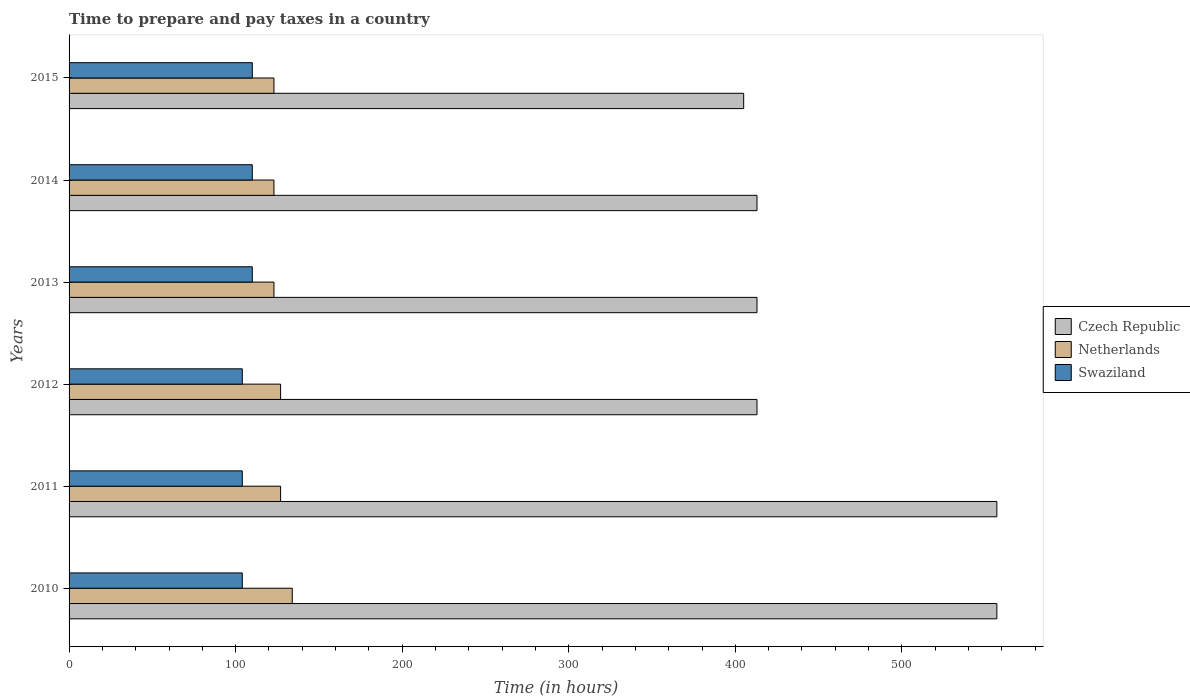How many groups of bars are there?
Make the answer very short. 6. Are the number of bars per tick equal to the number of legend labels?
Your response must be concise. Yes. Are the number of bars on each tick of the Y-axis equal?
Offer a very short reply. Yes. What is the label of the 6th group of bars from the top?
Your answer should be very brief. 2010. In how many cases, is the number of bars for a given year not equal to the number of legend labels?
Keep it short and to the point. 0. What is the number of hours required to prepare and pay taxes in Swaziland in 2011?
Your answer should be compact. 104. Across all years, what is the maximum number of hours required to prepare and pay taxes in Czech Republic?
Ensure brevity in your answer.  557. Across all years, what is the minimum number of hours required to prepare and pay taxes in Netherlands?
Provide a short and direct response. 123. In which year was the number of hours required to prepare and pay taxes in Czech Republic minimum?
Your response must be concise. 2015. What is the total number of hours required to prepare and pay taxes in Czech Republic in the graph?
Provide a short and direct response. 2758. What is the difference between the number of hours required to prepare and pay taxes in Netherlands in 2010 and that in 2012?
Provide a short and direct response. 7. What is the difference between the number of hours required to prepare and pay taxes in Netherlands in 2011 and the number of hours required to prepare and pay taxes in Swaziland in 2015?
Keep it short and to the point. 17. What is the average number of hours required to prepare and pay taxes in Czech Republic per year?
Make the answer very short. 459.67. In the year 2014, what is the difference between the number of hours required to prepare and pay taxes in Netherlands and number of hours required to prepare and pay taxes in Czech Republic?
Make the answer very short. -290. What is the ratio of the number of hours required to prepare and pay taxes in Czech Republic in 2011 to that in 2013?
Make the answer very short. 1.35. Is the difference between the number of hours required to prepare and pay taxes in Netherlands in 2011 and 2015 greater than the difference between the number of hours required to prepare and pay taxes in Czech Republic in 2011 and 2015?
Your answer should be very brief. No. What is the difference between the highest and the lowest number of hours required to prepare and pay taxes in Netherlands?
Offer a terse response. 11. In how many years, is the number of hours required to prepare and pay taxes in Swaziland greater than the average number of hours required to prepare and pay taxes in Swaziland taken over all years?
Your response must be concise. 3. Is the sum of the number of hours required to prepare and pay taxes in Netherlands in 2013 and 2015 greater than the maximum number of hours required to prepare and pay taxes in Czech Republic across all years?
Ensure brevity in your answer.  No. What does the 3rd bar from the top in 2015 represents?
Offer a very short reply. Czech Republic. What does the 2nd bar from the bottom in 2010 represents?
Make the answer very short. Netherlands. Is it the case that in every year, the sum of the number of hours required to prepare and pay taxes in Netherlands and number of hours required to prepare and pay taxes in Czech Republic is greater than the number of hours required to prepare and pay taxes in Swaziland?
Provide a succinct answer. Yes. How many years are there in the graph?
Keep it short and to the point. 6. Does the graph contain any zero values?
Keep it short and to the point. No. Where does the legend appear in the graph?
Ensure brevity in your answer.  Center right. How are the legend labels stacked?
Your answer should be very brief. Vertical. What is the title of the graph?
Offer a very short reply. Time to prepare and pay taxes in a country. Does "Azerbaijan" appear as one of the legend labels in the graph?
Provide a short and direct response. No. What is the label or title of the X-axis?
Provide a succinct answer. Time (in hours). What is the label or title of the Y-axis?
Give a very brief answer. Years. What is the Time (in hours) in Czech Republic in 2010?
Give a very brief answer. 557. What is the Time (in hours) in Netherlands in 2010?
Your answer should be very brief. 134. What is the Time (in hours) of Swaziland in 2010?
Give a very brief answer. 104. What is the Time (in hours) of Czech Republic in 2011?
Give a very brief answer. 557. What is the Time (in hours) of Netherlands in 2011?
Offer a terse response. 127. What is the Time (in hours) in Swaziland in 2011?
Make the answer very short. 104. What is the Time (in hours) in Czech Republic in 2012?
Offer a terse response. 413. What is the Time (in hours) in Netherlands in 2012?
Your answer should be very brief. 127. What is the Time (in hours) in Swaziland in 2012?
Your response must be concise. 104. What is the Time (in hours) of Czech Republic in 2013?
Provide a succinct answer. 413. What is the Time (in hours) of Netherlands in 2013?
Keep it short and to the point. 123. What is the Time (in hours) of Swaziland in 2013?
Offer a terse response. 110. What is the Time (in hours) in Czech Republic in 2014?
Make the answer very short. 413. What is the Time (in hours) in Netherlands in 2014?
Give a very brief answer. 123. What is the Time (in hours) of Swaziland in 2014?
Offer a terse response. 110. What is the Time (in hours) of Czech Republic in 2015?
Make the answer very short. 405. What is the Time (in hours) of Netherlands in 2015?
Your answer should be compact. 123. What is the Time (in hours) in Swaziland in 2015?
Give a very brief answer. 110. Across all years, what is the maximum Time (in hours) of Czech Republic?
Provide a succinct answer. 557. Across all years, what is the maximum Time (in hours) in Netherlands?
Offer a terse response. 134. Across all years, what is the maximum Time (in hours) of Swaziland?
Offer a terse response. 110. Across all years, what is the minimum Time (in hours) of Czech Republic?
Give a very brief answer. 405. Across all years, what is the minimum Time (in hours) in Netherlands?
Your response must be concise. 123. Across all years, what is the minimum Time (in hours) in Swaziland?
Give a very brief answer. 104. What is the total Time (in hours) of Czech Republic in the graph?
Provide a short and direct response. 2758. What is the total Time (in hours) of Netherlands in the graph?
Offer a very short reply. 757. What is the total Time (in hours) of Swaziland in the graph?
Keep it short and to the point. 642. What is the difference between the Time (in hours) of Czech Republic in 2010 and that in 2011?
Keep it short and to the point. 0. What is the difference between the Time (in hours) of Swaziland in 2010 and that in 2011?
Your answer should be compact. 0. What is the difference between the Time (in hours) in Czech Republic in 2010 and that in 2012?
Give a very brief answer. 144. What is the difference between the Time (in hours) in Netherlands in 2010 and that in 2012?
Give a very brief answer. 7. What is the difference between the Time (in hours) of Swaziland in 2010 and that in 2012?
Provide a short and direct response. 0. What is the difference between the Time (in hours) in Czech Republic in 2010 and that in 2013?
Your answer should be very brief. 144. What is the difference between the Time (in hours) of Swaziland in 2010 and that in 2013?
Make the answer very short. -6. What is the difference between the Time (in hours) in Czech Republic in 2010 and that in 2014?
Offer a very short reply. 144. What is the difference between the Time (in hours) in Netherlands in 2010 and that in 2014?
Provide a short and direct response. 11. What is the difference between the Time (in hours) in Czech Republic in 2010 and that in 2015?
Make the answer very short. 152. What is the difference between the Time (in hours) in Netherlands in 2010 and that in 2015?
Ensure brevity in your answer.  11. What is the difference between the Time (in hours) in Swaziland in 2010 and that in 2015?
Offer a terse response. -6. What is the difference between the Time (in hours) of Czech Republic in 2011 and that in 2012?
Provide a succinct answer. 144. What is the difference between the Time (in hours) of Czech Republic in 2011 and that in 2013?
Ensure brevity in your answer.  144. What is the difference between the Time (in hours) of Netherlands in 2011 and that in 2013?
Keep it short and to the point. 4. What is the difference between the Time (in hours) in Czech Republic in 2011 and that in 2014?
Ensure brevity in your answer.  144. What is the difference between the Time (in hours) in Netherlands in 2011 and that in 2014?
Provide a short and direct response. 4. What is the difference between the Time (in hours) of Swaziland in 2011 and that in 2014?
Offer a terse response. -6. What is the difference between the Time (in hours) of Czech Republic in 2011 and that in 2015?
Give a very brief answer. 152. What is the difference between the Time (in hours) of Netherlands in 2011 and that in 2015?
Provide a short and direct response. 4. What is the difference between the Time (in hours) in Czech Republic in 2012 and that in 2013?
Give a very brief answer. 0. What is the difference between the Time (in hours) in Netherlands in 2012 and that in 2013?
Your answer should be compact. 4. What is the difference between the Time (in hours) of Netherlands in 2013 and that in 2014?
Offer a very short reply. 0. What is the difference between the Time (in hours) in Czech Republic in 2013 and that in 2015?
Make the answer very short. 8. What is the difference between the Time (in hours) of Netherlands in 2013 and that in 2015?
Keep it short and to the point. 0. What is the difference between the Time (in hours) of Czech Republic in 2014 and that in 2015?
Ensure brevity in your answer.  8. What is the difference between the Time (in hours) in Swaziland in 2014 and that in 2015?
Keep it short and to the point. 0. What is the difference between the Time (in hours) of Czech Republic in 2010 and the Time (in hours) of Netherlands in 2011?
Give a very brief answer. 430. What is the difference between the Time (in hours) in Czech Republic in 2010 and the Time (in hours) in Swaziland in 2011?
Keep it short and to the point. 453. What is the difference between the Time (in hours) of Netherlands in 2010 and the Time (in hours) of Swaziland in 2011?
Keep it short and to the point. 30. What is the difference between the Time (in hours) in Czech Republic in 2010 and the Time (in hours) in Netherlands in 2012?
Offer a terse response. 430. What is the difference between the Time (in hours) of Czech Republic in 2010 and the Time (in hours) of Swaziland in 2012?
Provide a succinct answer. 453. What is the difference between the Time (in hours) of Czech Republic in 2010 and the Time (in hours) of Netherlands in 2013?
Ensure brevity in your answer.  434. What is the difference between the Time (in hours) in Czech Republic in 2010 and the Time (in hours) in Swaziland in 2013?
Ensure brevity in your answer.  447. What is the difference between the Time (in hours) in Netherlands in 2010 and the Time (in hours) in Swaziland in 2013?
Offer a terse response. 24. What is the difference between the Time (in hours) in Czech Republic in 2010 and the Time (in hours) in Netherlands in 2014?
Your answer should be very brief. 434. What is the difference between the Time (in hours) of Czech Republic in 2010 and the Time (in hours) of Swaziland in 2014?
Your response must be concise. 447. What is the difference between the Time (in hours) in Czech Republic in 2010 and the Time (in hours) in Netherlands in 2015?
Offer a terse response. 434. What is the difference between the Time (in hours) in Czech Republic in 2010 and the Time (in hours) in Swaziland in 2015?
Make the answer very short. 447. What is the difference between the Time (in hours) of Netherlands in 2010 and the Time (in hours) of Swaziland in 2015?
Make the answer very short. 24. What is the difference between the Time (in hours) of Czech Republic in 2011 and the Time (in hours) of Netherlands in 2012?
Keep it short and to the point. 430. What is the difference between the Time (in hours) of Czech Republic in 2011 and the Time (in hours) of Swaziland in 2012?
Offer a very short reply. 453. What is the difference between the Time (in hours) in Netherlands in 2011 and the Time (in hours) in Swaziland in 2012?
Offer a very short reply. 23. What is the difference between the Time (in hours) of Czech Republic in 2011 and the Time (in hours) of Netherlands in 2013?
Your answer should be very brief. 434. What is the difference between the Time (in hours) in Czech Republic in 2011 and the Time (in hours) in Swaziland in 2013?
Ensure brevity in your answer.  447. What is the difference between the Time (in hours) in Czech Republic in 2011 and the Time (in hours) in Netherlands in 2014?
Your response must be concise. 434. What is the difference between the Time (in hours) of Czech Republic in 2011 and the Time (in hours) of Swaziland in 2014?
Offer a very short reply. 447. What is the difference between the Time (in hours) in Netherlands in 2011 and the Time (in hours) in Swaziland in 2014?
Your answer should be very brief. 17. What is the difference between the Time (in hours) in Czech Republic in 2011 and the Time (in hours) in Netherlands in 2015?
Your answer should be compact. 434. What is the difference between the Time (in hours) of Czech Republic in 2011 and the Time (in hours) of Swaziland in 2015?
Your answer should be compact. 447. What is the difference between the Time (in hours) in Netherlands in 2011 and the Time (in hours) in Swaziland in 2015?
Make the answer very short. 17. What is the difference between the Time (in hours) of Czech Republic in 2012 and the Time (in hours) of Netherlands in 2013?
Keep it short and to the point. 290. What is the difference between the Time (in hours) of Czech Republic in 2012 and the Time (in hours) of Swaziland in 2013?
Offer a terse response. 303. What is the difference between the Time (in hours) in Czech Republic in 2012 and the Time (in hours) in Netherlands in 2014?
Offer a terse response. 290. What is the difference between the Time (in hours) of Czech Republic in 2012 and the Time (in hours) of Swaziland in 2014?
Provide a succinct answer. 303. What is the difference between the Time (in hours) of Czech Republic in 2012 and the Time (in hours) of Netherlands in 2015?
Ensure brevity in your answer.  290. What is the difference between the Time (in hours) of Czech Republic in 2012 and the Time (in hours) of Swaziland in 2015?
Keep it short and to the point. 303. What is the difference between the Time (in hours) in Netherlands in 2012 and the Time (in hours) in Swaziland in 2015?
Give a very brief answer. 17. What is the difference between the Time (in hours) of Czech Republic in 2013 and the Time (in hours) of Netherlands in 2014?
Offer a very short reply. 290. What is the difference between the Time (in hours) in Czech Republic in 2013 and the Time (in hours) in Swaziland in 2014?
Offer a very short reply. 303. What is the difference between the Time (in hours) in Czech Republic in 2013 and the Time (in hours) in Netherlands in 2015?
Offer a terse response. 290. What is the difference between the Time (in hours) in Czech Republic in 2013 and the Time (in hours) in Swaziland in 2015?
Your answer should be very brief. 303. What is the difference between the Time (in hours) in Netherlands in 2013 and the Time (in hours) in Swaziland in 2015?
Your answer should be very brief. 13. What is the difference between the Time (in hours) in Czech Republic in 2014 and the Time (in hours) in Netherlands in 2015?
Your answer should be compact. 290. What is the difference between the Time (in hours) of Czech Republic in 2014 and the Time (in hours) of Swaziland in 2015?
Your answer should be very brief. 303. What is the difference between the Time (in hours) in Netherlands in 2014 and the Time (in hours) in Swaziland in 2015?
Offer a very short reply. 13. What is the average Time (in hours) in Czech Republic per year?
Give a very brief answer. 459.67. What is the average Time (in hours) in Netherlands per year?
Provide a short and direct response. 126.17. What is the average Time (in hours) in Swaziland per year?
Make the answer very short. 107. In the year 2010, what is the difference between the Time (in hours) in Czech Republic and Time (in hours) in Netherlands?
Provide a short and direct response. 423. In the year 2010, what is the difference between the Time (in hours) of Czech Republic and Time (in hours) of Swaziland?
Provide a short and direct response. 453. In the year 2010, what is the difference between the Time (in hours) of Netherlands and Time (in hours) of Swaziland?
Give a very brief answer. 30. In the year 2011, what is the difference between the Time (in hours) of Czech Republic and Time (in hours) of Netherlands?
Your answer should be very brief. 430. In the year 2011, what is the difference between the Time (in hours) of Czech Republic and Time (in hours) of Swaziland?
Keep it short and to the point. 453. In the year 2011, what is the difference between the Time (in hours) in Netherlands and Time (in hours) in Swaziland?
Your response must be concise. 23. In the year 2012, what is the difference between the Time (in hours) of Czech Republic and Time (in hours) of Netherlands?
Offer a terse response. 286. In the year 2012, what is the difference between the Time (in hours) of Czech Republic and Time (in hours) of Swaziland?
Offer a terse response. 309. In the year 2012, what is the difference between the Time (in hours) of Netherlands and Time (in hours) of Swaziland?
Offer a very short reply. 23. In the year 2013, what is the difference between the Time (in hours) of Czech Republic and Time (in hours) of Netherlands?
Offer a very short reply. 290. In the year 2013, what is the difference between the Time (in hours) in Czech Republic and Time (in hours) in Swaziland?
Offer a very short reply. 303. In the year 2014, what is the difference between the Time (in hours) in Czech Republic and Time (in hours) in Netherlands?
Your answer should be very brief. 290. In the year 2014, what is the difference between the Time (in hours) of Czech Republic and Time (in hours) of Swaziland?
Offer a very short reply. 303. In the year 2015, what is the difference between the Time (in hours) of Czech Republic and Time (in hours) of Netherlands?
Keep it short and to the point. 282. In the year 2015, what is the difference between the Time (in hours) of Czech Republic and Time (in hours) of Swaziland?
Give a very brief answer. 295. What is the ratio of the Time (in hours) of Netherlands in 2010 to that in 2011?
Provide a short and direct response. 1.06. What is the ratio of the Time (in hours) of Swaziland in 2010 to that in 2011?
Ensure brevity in your answer.  1. What is the ratio of the Time (in hours) of Czech Republic in 2010 to that in 2012?
Provide a short and direct response. 1.35. What is the ratio of the Time (in hours) in Netherlands in 2010 to that in 2012?
Your answer should be very brief. 1.06. What is the ratio of the Time (in hours) of Czech Republic in 2010 to that in 2013?
Your answer should be very brief. 1.35. What is the ratio of the Time (in hours) in Netherlands in 2010 to that in 2013?
Your response must be concise. 1.09. What is the ratio of the Time (in hours) of Swaziland in 2010 to that in 2013?
Your response must be concise. 0.95. What is the ratio of the Time (in hours) in Czech Republic in 2010 to that in 2014?
Ensure brevity in your answer.  1.35. What is the ratio of the Time (in hours) of Netherlands in 2010 to that in 2014?
Your response must be concise. 1.09. What is the ratio of the Time (in hours) of Swaziland in 2010 to that in 2014?
Keep it short and to the point. 0.95. What is the ratio of the Time (in hours) in Czech Republic in 2010 to that in 2015?
Offer a terse response. 1.38. What is the ratio of the Time (in hours) in Netherlands in 2010 to that in 2015?
Offer a terse response. 1.09. What is the ratio of the Time (in hours) in Swaziland in 2010 to that in 2015?
Offer a terse response. 0.95. What is the ratio of the Time (in hours) of Czech Republic in 2011 to that in 2012?
Offer a very short reply. 1.35. What is the ratio of the Time (in hours) of Czech Republic in 2011 to that in 2013?
Your answer should be very brief. 1.35. What is the ratio of the Time (in hours) of Netherlands in 2011 to that in 2013?
Keep it short and to the point. 1.03. What is the ratio of the Time (in hours) of Swaziland in 2011 to that in 2013?
Make the answer very short. 0.95. What is the ratio of the Time (in hours) of Czech Republic in 2011 to that in 2014?
Your answer should be compact. 1.35. What is the ratio of the Time (in hours) of Netherlands in 2011 to that in 2014?
Your answer should be compact. 1.03. What is the ratio of the Time (in hours) in Swaziland in 2011 to that in 2014?
Your answer should be compact. 0.95. What is the ratio of the Time (in hours) in Czech Republic in 2011 to that in 2015?
Provide a short and direct response. 1.38. What is the ratio of the Time (in hours) of Netherlands in 2011 to that in 2015?
Provide a short and direct response. 1.03. What is the ratio of the Time (in hours) in Swaziland in 2011 to that in 2015?
Your answer should be compact. 0.95. What is the ratio of the Time (in hours) in Czech Republic in 2012 to that in 2013?
Your response must be concise. 1. What is the ratio of the Time (in hours) of Netherlands in 2012 to that in 2013?
Your response must be concise. 1.03. What is the ratio of the Time (in hours) of Swaziland in 2012 to that in 2013?
Provide a short and direct response. 0.95. What is the ratio of the Time (in hours) in Czech Republic in 2012 to that in 2014?
Provide a succinct answer. 1. What is the ratio of the Time (in hours) in Netherlands in 2012 to that in 2014?
Your answer should be very brief. 1.03. What is the ratio of the Time (in hours) of Swaziland in 2012 to that in 2014?
Provide a short and direct response. 0.95. What is the ratio of the Time (in hours) of Czech Republic in 2012 to that in 2015?
Ensure brevity in your answer.  1.02. What is the ratio of the Time (in hours) in Netherlands in 2012 to that in 2015?
Your answer should be compact. 1.03. What is the ratio of the Time (in hours) of Swaziland in 2012 to that in 2015?
Make the answer very short. 0.95. What is the ratio of the Time (in hours) in Netherlands in 2013 to that in 2014?
Your answer should be very brief. 1. What is the ratio of the Time (in hours) in Czech Republic in 2013 to that in 2015?
Give a very brief answer. 1.02. What is the ratio of the Time (in hours) of Czech Republic in 2014 to that in 2015?
Your answer should be very brief. 1.02. What is the ratio of the Time (in hours) of Swaziland in 2014 to that in 2015?
Keep it short and to the point. 1. What is the difference between the highest and the lowest Time (in hours) of Czech Republic?
Offer a terse response. 152. 